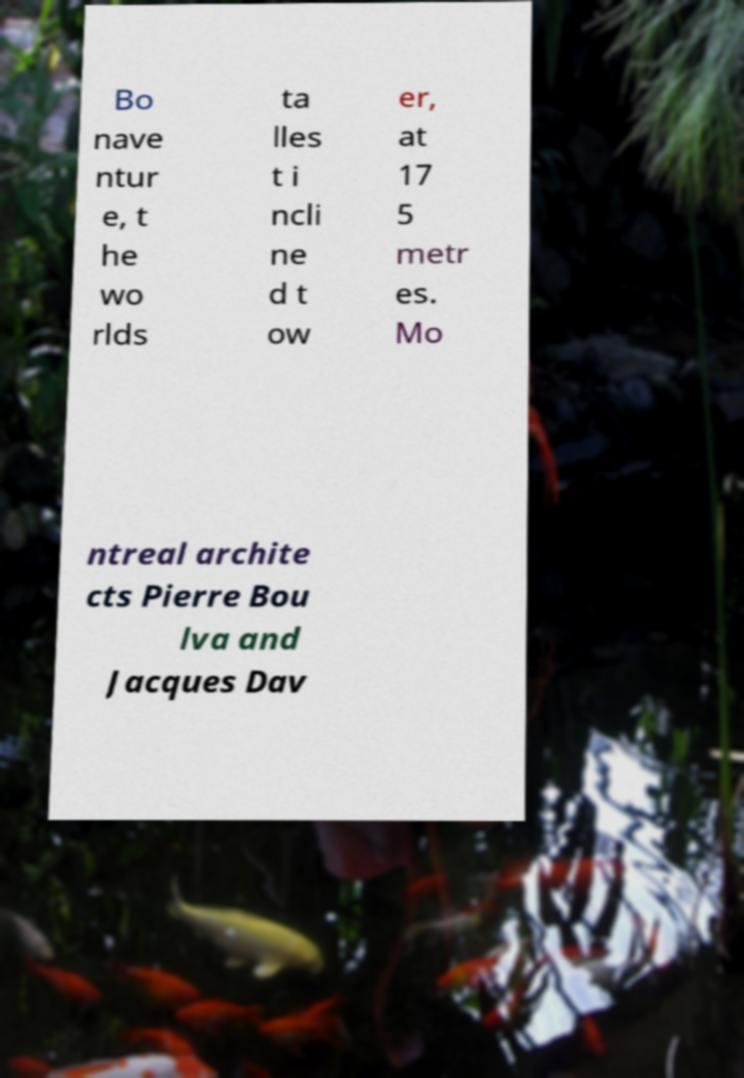Could you extract and type out the text from this image? Bo nave ntur e, t he wo rlds ta lles t i ncli ne d t ow er, at 17 5 metr es. Mo ntreal archite cts Pierre Bou lva and Jacques Dav 